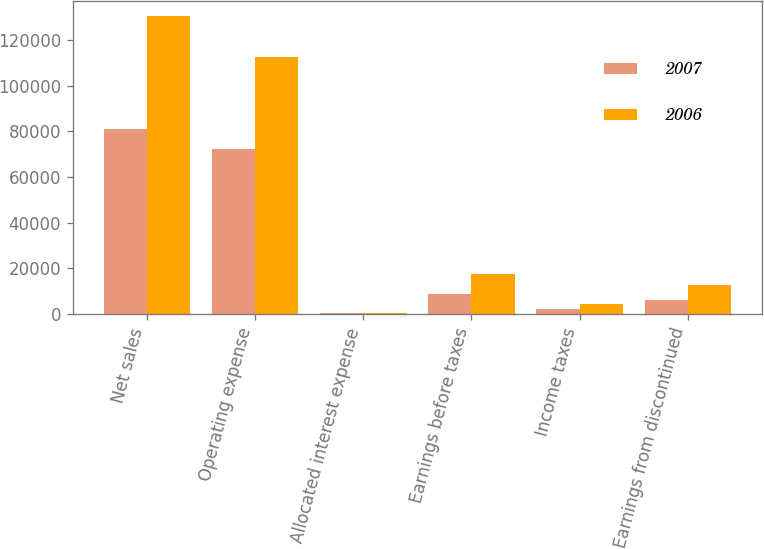<chart> <loc_0><loc_0><loc_500><loc_500><stacked_bar_chart><ecel><fcel>Net sales<fcel>Operating expense<fcel>Allocated interest expense<fcel>Earnings before taxes<fcel>Income taxes<fcel>Earnings from discontinued<nl><fcel>2007<fcel>81141<fcel>72239<fcel>351<fcel>8551<fcel>2279<fcel>6272<nl><fcel>2006<fcel>130348<fcel>112565<fcel>454<fcel>17329<fcel>4506<fcel>12823<nl></chart> 